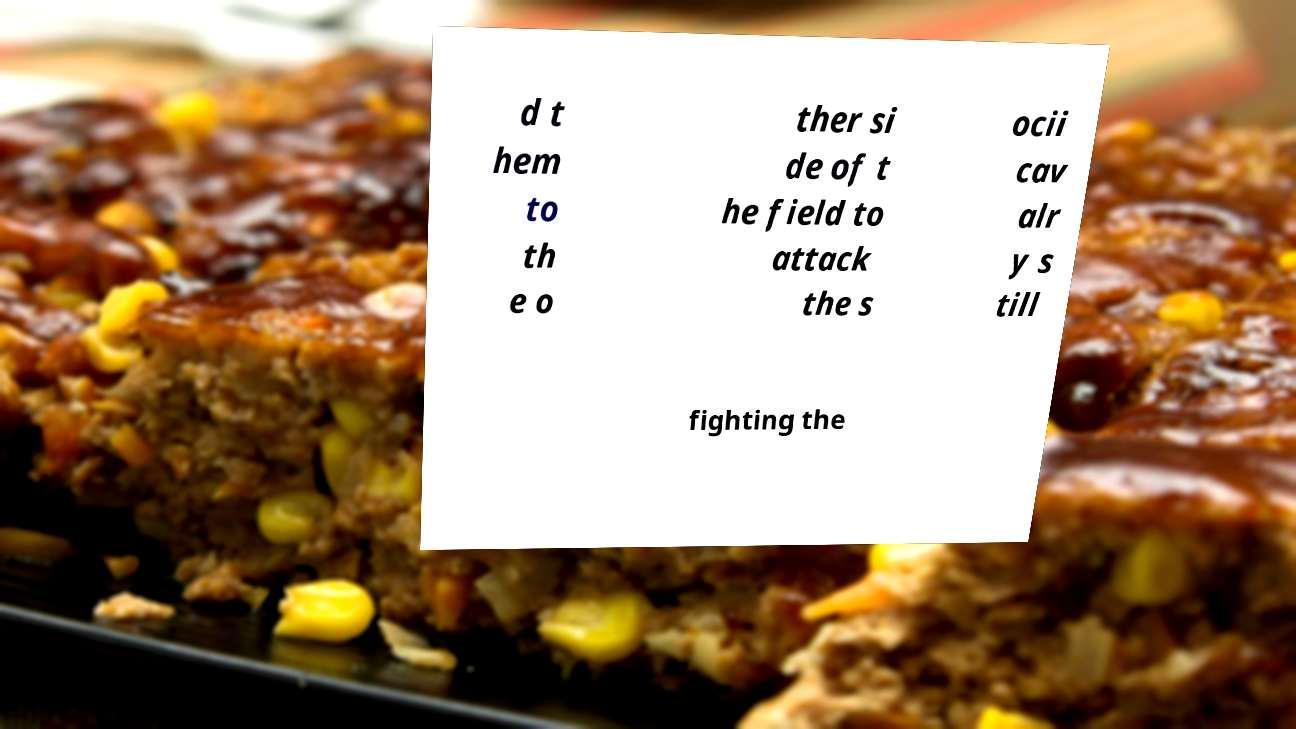What messages or text are displayed in this image? I need them in a readable, typed format. d t hem to th e o ther si de of t he field to attack the s ocii cav alr y s till fighting the 